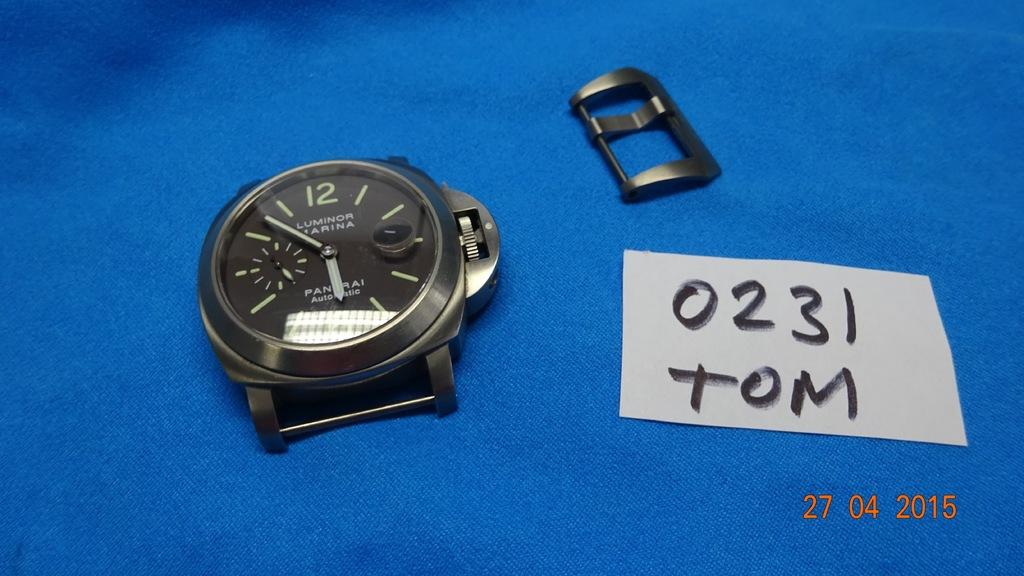<image>
Render a clear and concise summary of the photo. A gray metal analog watch face with a watch closure piece on a blue tarp beside a written note reading TOM 